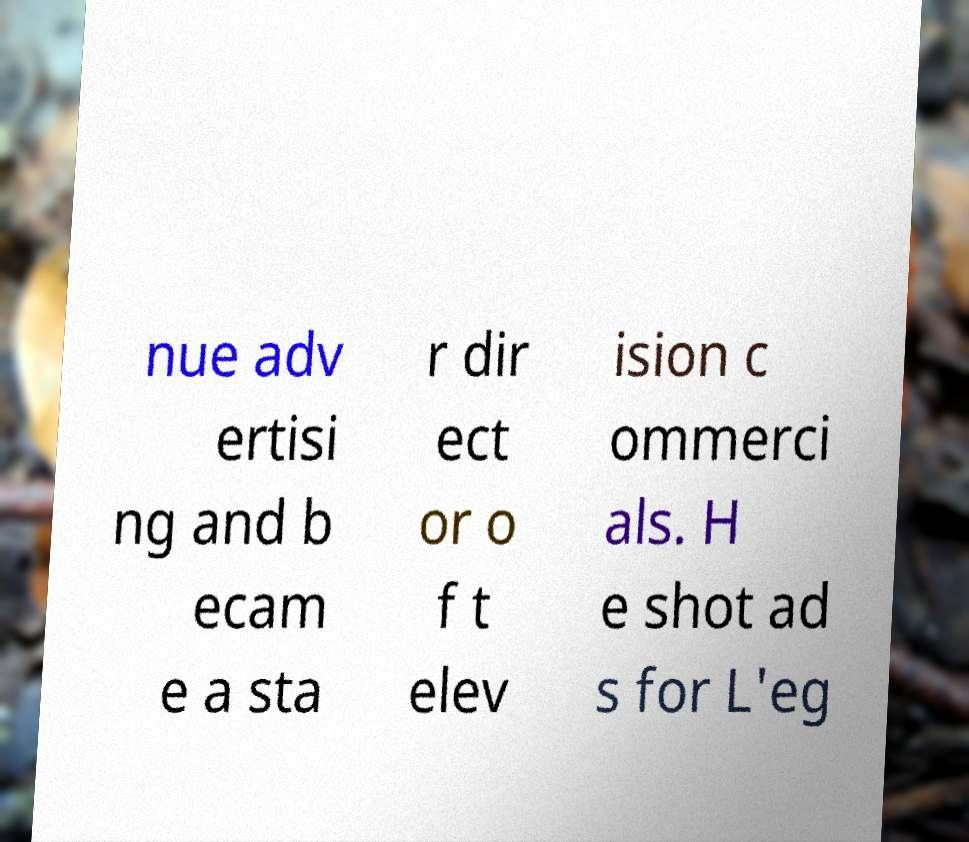Can you accurately transcribe the text from the provided image for me? nue adv ertisi ng and b ecam e a sta r dir ect or o f t elev ision c ommerci als. H e shot ad s for L'eg 